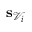<formula> <loc_0><loc_0><loc_500><loc_500>s _ { \mathcal { V } _ { i } }</formula> 